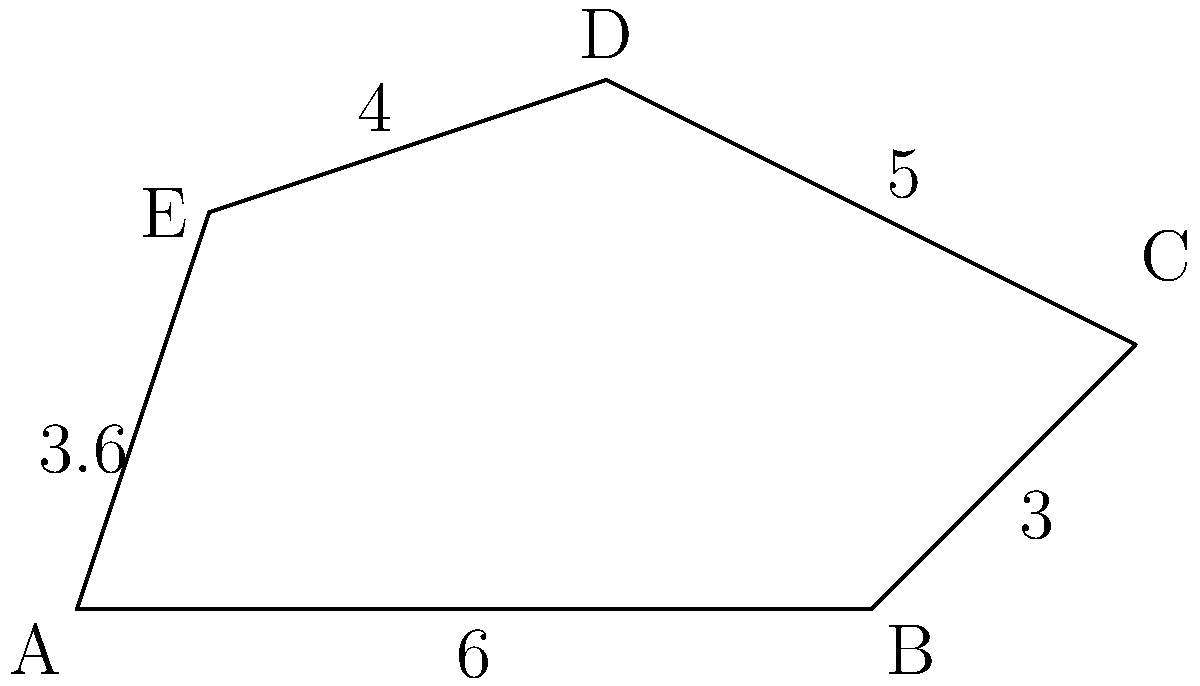As a financial regulator overseeing venture capital activities, you're analyzing market segments represented by an irregular polygon ABCDE. Given the side lengths AB = 6 units, BC = 3 units, CD = 5 units, DE = 4 units, and EA = 3.6 units, calculate the perimeter of this polygon representing the total market coverage. To calculate the perimeter of the irregular polygon ABCDE, we need to sum up the lengths of all sides. Let's break it down step-by-step:

1. Side AB = 6 units
2. Side BC = 3 units
3. Side CD = 5 units
4. Side DE = 4 units
5. Side EA = 3.6 units

Now, we can calculate the perimeter by adding all these lengths:

$$\text{Perimeter} = AB + BC + CD + DE + EA$$
$$\text{Perimeter} = 6 + 3 + 5 + 4 + 3.6$$
$$\text{Perimeter} = 21.6 \text{ units}$$

This result represents the total market coverage in the context of venture capital activities, where each side of the polygon corresponds to a different market segment.
Answer: 21.6 units 